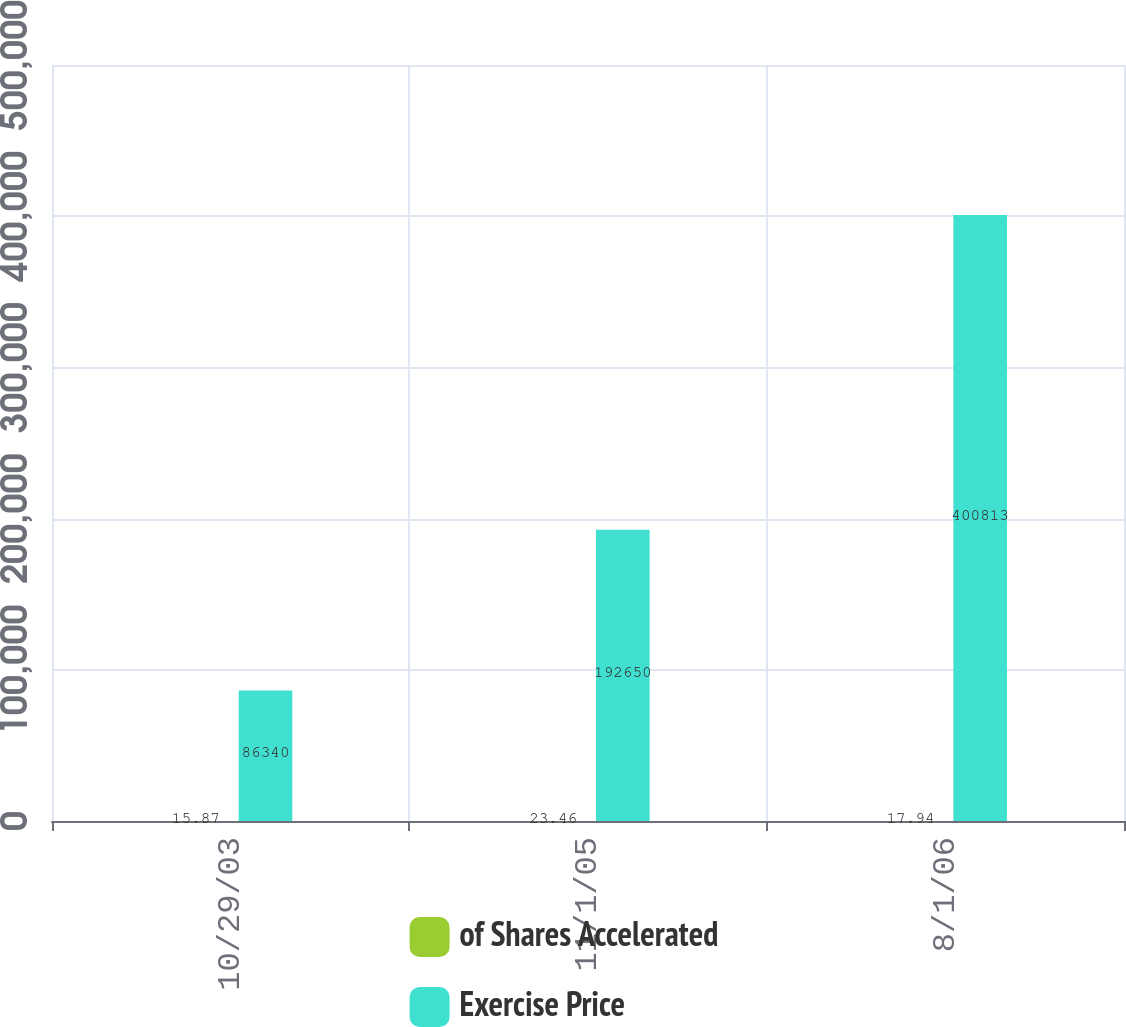<chart> <loc_0><loc_0><loc_500><loc_500><stacked_bar_chart><ecel><fcel>10/29/03<fcel>11/1/05<fcel>8/1/06<nl><fcel>of Shares Accelerated<fcel>15.87<fcel>23.46<fcel>17.94<nl><fcel>Exercise Price<fcel>86340<fcel>192650<fcel>400813<nl></chart> 